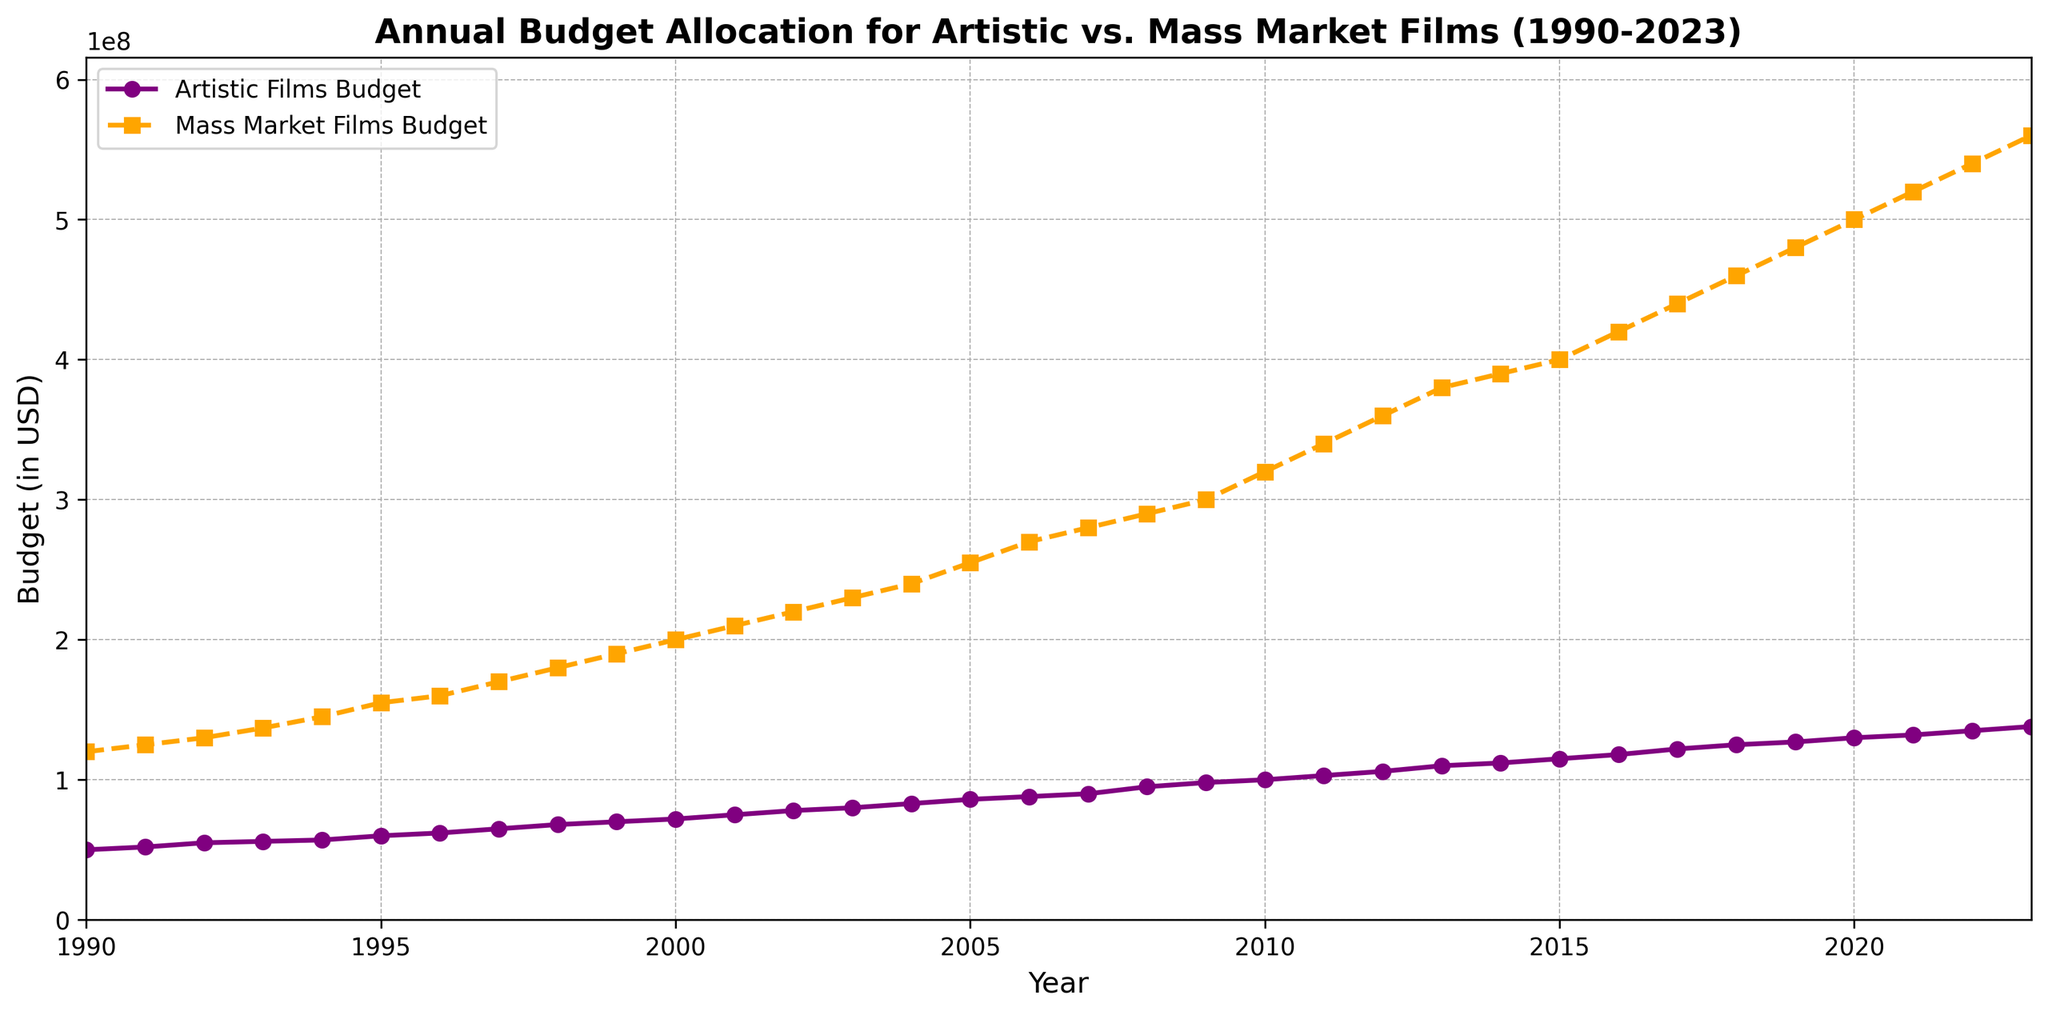Which year shows the highest budget allocation for mass-market films? To find this, look for the highest point on the line representing mass-market films (usually orange with a specific marker). According to the chart, the year 2023 shows the peak budget allocation for mass-market films.
Answer: 2023 Which year had the smallest gap between the budgets of artistic films and mass-market films? The gap can be visually assessed by how close the two lines (purple for artistic and orange for mass market) are. The smallest vertical distance appears in 1990, where the difference seems the smallest.
Answer: 1990 How has the budget for artistic films changed over the years, and how does it compare to mass-market films? Observe the trend lines for both budgets. The artistic films' budget shows a consistent, gradual increase without sharp spikes or dips, similar to but less steep than the mass-market films' budget, indicating a steadier rate of increase.
Answer: Both gradually increase; artistic films at a steadier rate What is the rate of increase in the budget for artistic films from 2000 to 2023? Calculate the difference in budgets between 2000 and 2023 for artistic films then divide by the number of years. From the data, 138,000,000 (2023) - 72,000,000 (2000) = 66,000,000 increase over 23 years, resulting in approximately 2,869,565 per year.
Answer: 2,869,565 per year In which decade did the mass-market film budget see the most significant increase? Compare the slope of the mass-market film budget line in each decade. From 2010 to 2020, the line is steeper compared to other decades, indicating the most significant budget increase occurred in that period.
Answer: 2010-2020 What is the difference in the budget between artistic and mass-market films in 2023? Look at the y-axis values for both types in 2023. Artistic films have a budget of 138,000,000 and mass-market films 560,000,000. Subtract these values to find the difference: 560,000,000 - 138,000,000 = 422,000,000.
Answer: 422,000,000 Between which consecutive years did artistic films see the largest budget increase? Examine the artistic films' line to spot the steepest segment. The largest annual increase for artistic films occurs between 2002 and 2003.
Answer: 2002-2003 What is the average budget allocation for artistic films over the period 1990-2023? Sum all the yearly budgets for artistic films and then divide by the number of years (34 years). Sum: 2,908,000,000; divide by 34: 2,908,000,000 / 34 = approximately 85,529,412.
Answer: 85,529,412 